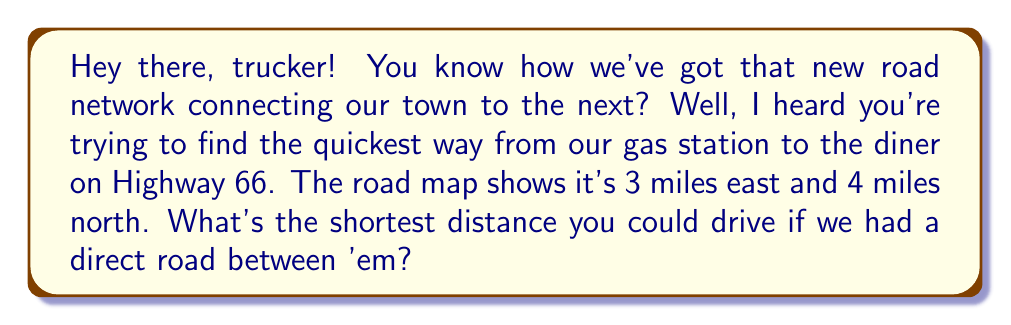Show me your answer to this math problem. Alright, let's break this down step-by-step:

1) This problem is a perfect application of the Pythagorean theorem. We can think of the road network as forming a right triangle.

2) The two known sides of this triangle are:
   - 3 miles east (let's call this $a$)
   - 4 miles north (let's call this $b$)

3) We're looking for the hypotenuse of this triangle, which would represent the shortest possible route. Let's call this distance $c$.

4) The Pythagorean theorem states that in a right triangle:

   $$a^2 + b^2 = c^2$$

5) Let's plug in our values:

   $$3^2 + 4^2 = c^2$$

6) Simplify:

   $$9 + 16 = c^2$$
   $$25 = c^2$$

7) To find $c$, we need to take the square root of both sides:

   $$\sqrt{25} = c$$

8) Simplify:

   $$5 = c$$

Therefore, the shortest possible route would be 5 miles.

[asy]
unitsize(1cm);
draw((0,0)--(3,0)--(3,4)--(0,0),black);
label("3 miles", (1.5,0), S);
label("4 miles", (3,2), E);
label("5 miles", (1.5,2), NW);
dot((0,0));
dot((3,4));
[/asy]
Answer: 5 miles 